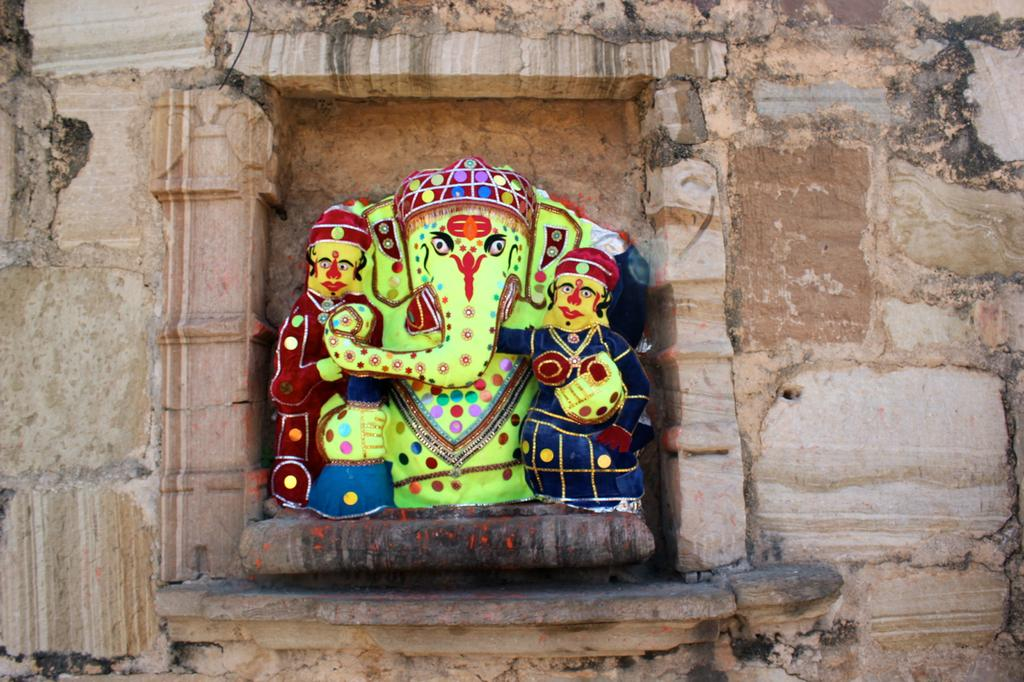What type of structure is depicted in the image? There is a historical wall in the image. What can be seen on the wall? There is a god Ganesha sculpture and two person sculptures on the wall. Where is the tent located in the image? There is no tent present in the image. What type of bone is visible in the image? There are no bones visible in the image. 